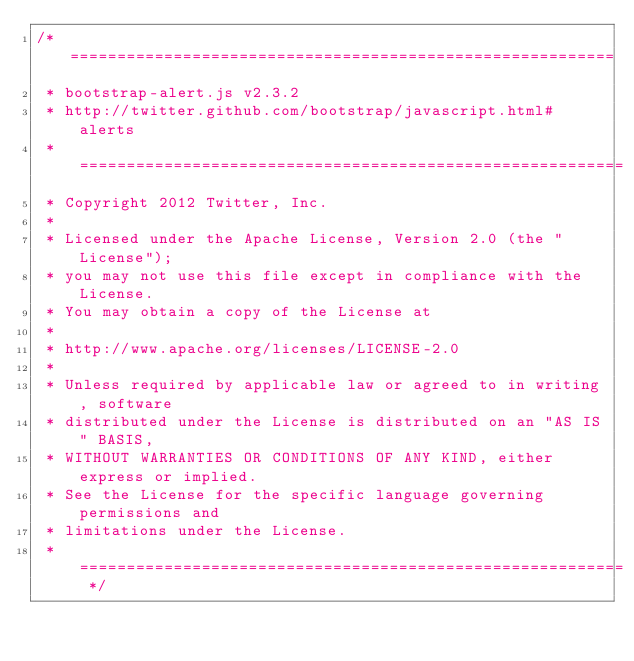Convert code to text. <code><loc_0><loc_0><loc_500><loc_500><_JavaScript_>/* ==========================================================
 * bootstrap-alert.js v2.3.2
 * http://twitter.github.com/bootstrap/javascript.html#alerts
 * ==========================================================
 * Copyright 2012 Twitter, Inc.
 *
 * Licensed under the Apache License, Version 2.0 (the "License");
 * you may not use this file except in compliance with the License.
 * You may obtain a copy of the License at
 *
 * http://www.apache.org/licenses/LICENSE-2.0
 *
 * Unless required by applicable law or agreed to in writing, software
 * distributed under the License is distributed on an "AS IS" BASIS,
 * WITHOUT WARRANTIES OR CONDITIONS OF ANY KIND, either express or implied.
 * See the License for the specific language governing permissions and
 * limitations under the License.
 * ========================================================== */</code> 